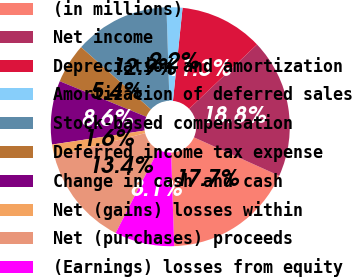Convert chart to OTSL. <chart><loc_0><loc_0><loc_500><loc_500><pie_chart><fcel>(in millions)<fcel>Net income<fcel>Depreciation and amortization<fcel>Amortization of deferred sales<fcel>Stock-based compensation<fcel>Deferred income tax expense<fcel>Change in cash and cash<fcel>Net (gains) losses within<fcel>Net (purchases) proceeds<fcel>(Earnings) losses from equity<nl><fcel>17.74%<fcel>18.81%<fcel>11.29%<fcel>2.15%<fcel>12.9%<fcel>5.38%<fcel>8.6%<fcel>1.62%<fcel>13.44%<fcel>8.07%<nl></chart> 